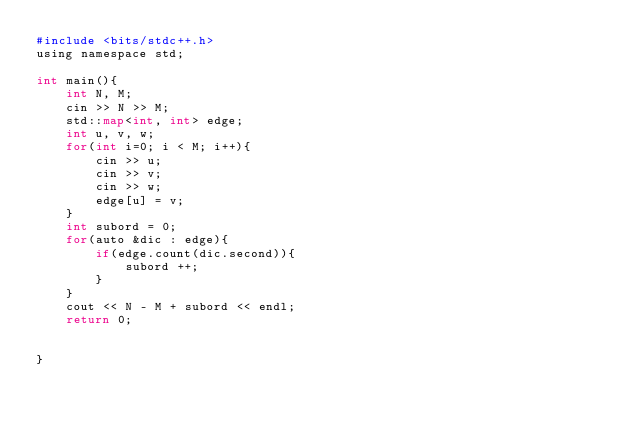Convert code to text. <code><loc_0><loc_0><loc_500><loc_500><_Python_>#include <bits/stdc++.h>
using namespace std;

int main(){
    int N, M;
    cin >> N >> M;
    std::map<int, int> edge;
    int u, v, w;
    for(int i=0; i < M; i++){
        cin >> u;
        cin >> v;
        cin >> w;
        edge[u] = v;
    }
    int subord = 0;
    for(auto &dic : edge){
        if(edge.count(dic.second)){
            subord ++;
        }
    }
    cout << N - M + subord << endl;
    return 0;


}
</code> 